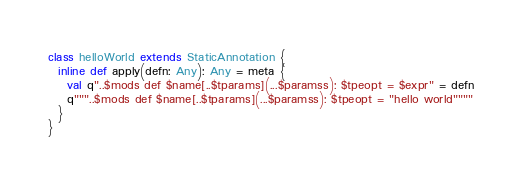Convert code to text. <code><loc_0><loc_0><loc_500><loc_500><_Scala_>
class helloWorld extends StaticAnnotation {
  inline def apply(defn: Any): Any = meta {
    val q"..$mods def $name[..$tparams](...$paramss): $tpeopt = $expr" = defn
    q"""..$mods def $name[..$tparams](...$paramss): $tpeopt = "hello world""""
  }
}</code> 